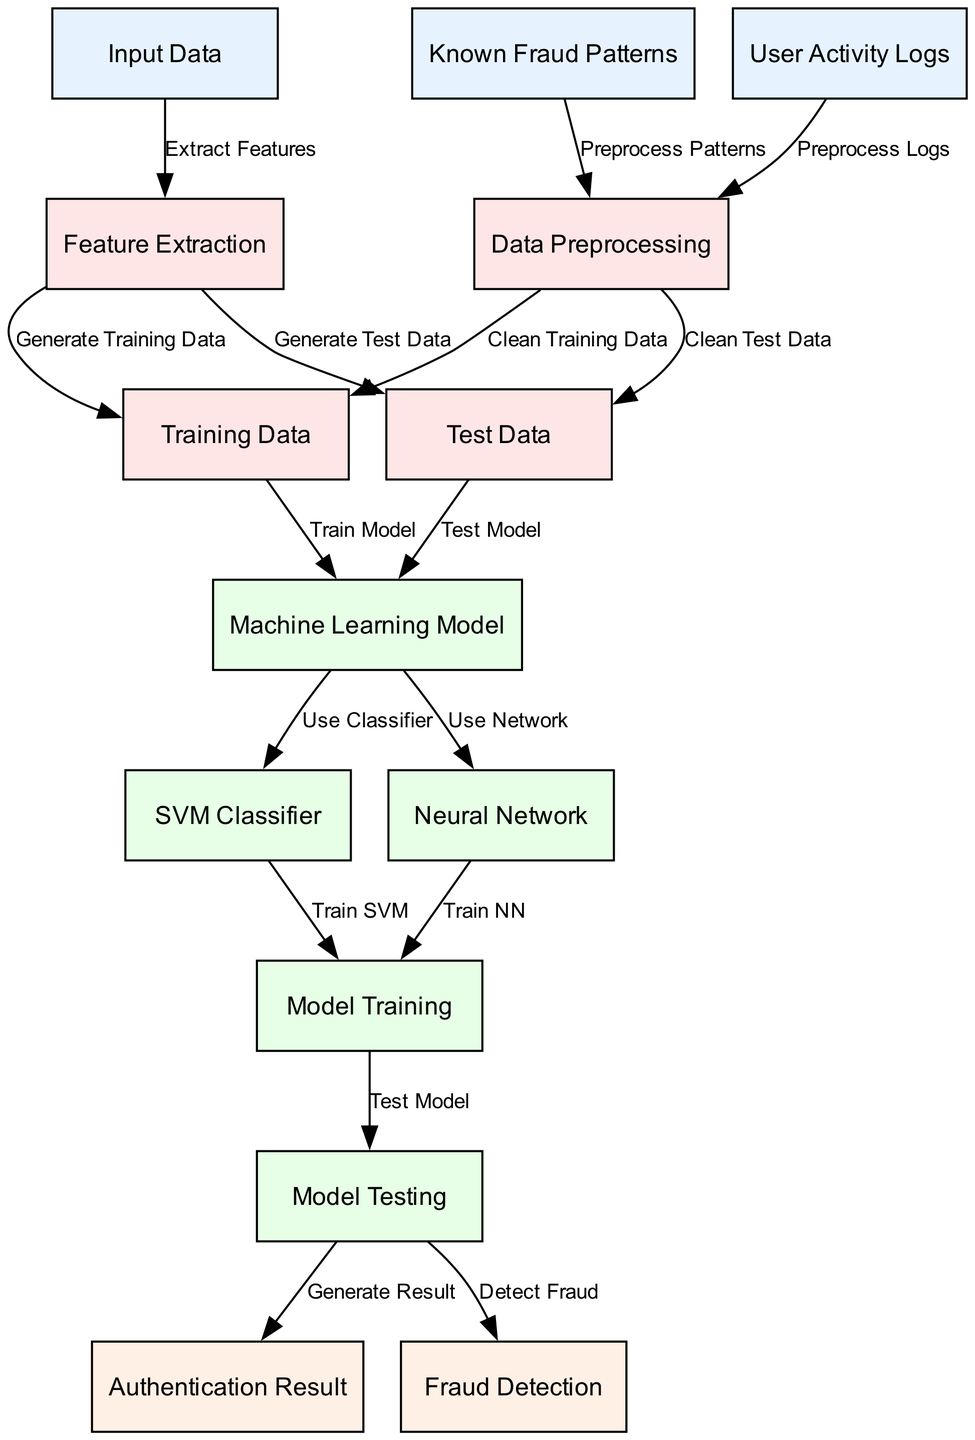What are the main sources of input data in this diagram? The main sources of input data are "User Activity Logs" and "Known Fraud Patterns." These are the nodes directly connected to the "Data Preprocessing" stage and provide information for feature extraction and further analysis.
Answer: User Activity Logs, Known Fraud Patterns How many primary machine learning models are used in this diagram? There are two primary machine learning models indicated in the diagram: "SVM Classifier" and "Neural Network." These models are derived from the "Machine Learning Model" node, both serving as classifiers for authentication and fraud detection.
Answer: Two What is the relationship between the "Model Training" and "Model Testing" nodes? The relationship is that "Model Training" uses the outputs from the training data to develop the model, after which "Model Testing" occurs to evaluate the model's performance. This causal flow demonstrates the sequential steps in the machine learning process.
Answer: Train then Test What is the purpose of the "Data Preprocessing" step in the diagram? The purpose of the "Data Preprocessing" step is to clean both the "Training Data" and "Test Data." This ensures that the information fed into the models is accurate and reliable, improving the effectiveness of subsequent training and testing phases.
Answer: Clean Data Which node directly leads to the "Authentication Result" and "Fraud Detection" nodes? The "Model Testing" node directly leads to both the "Authentication Result" and "Fraud Detection" nodes. This indicates that after testing the models, the outcomes for authentication and detection are generated.
Answer: Model Testing What process follows the extraction of features from the input data? The process that follows feature extraction is "Data Preprocessing," which prepares the training and test data for model training and evaluation. This is crucial for ensuring quality data input in the machine learning models.
Answer: Data Preprocessing How many edges connect input data to the preprocessing stage? There are two edges connecting input data to the preprocessing stage, specifically from "User Activity Logs" and "Known Fraud Patterns." Both edges represent the flow of information into the preprocessing process, preparing it for later steps.
Answer: Two What types of classifiers are utilized in the machine learning model? The classifiers utilized are "SVM Classifier" and "Neural Network." Each serves as a mechanism for analysis within the overall machine learning framework focused on user authentication and fraud detection.
Answer: SVM Classifier, Neural Network 